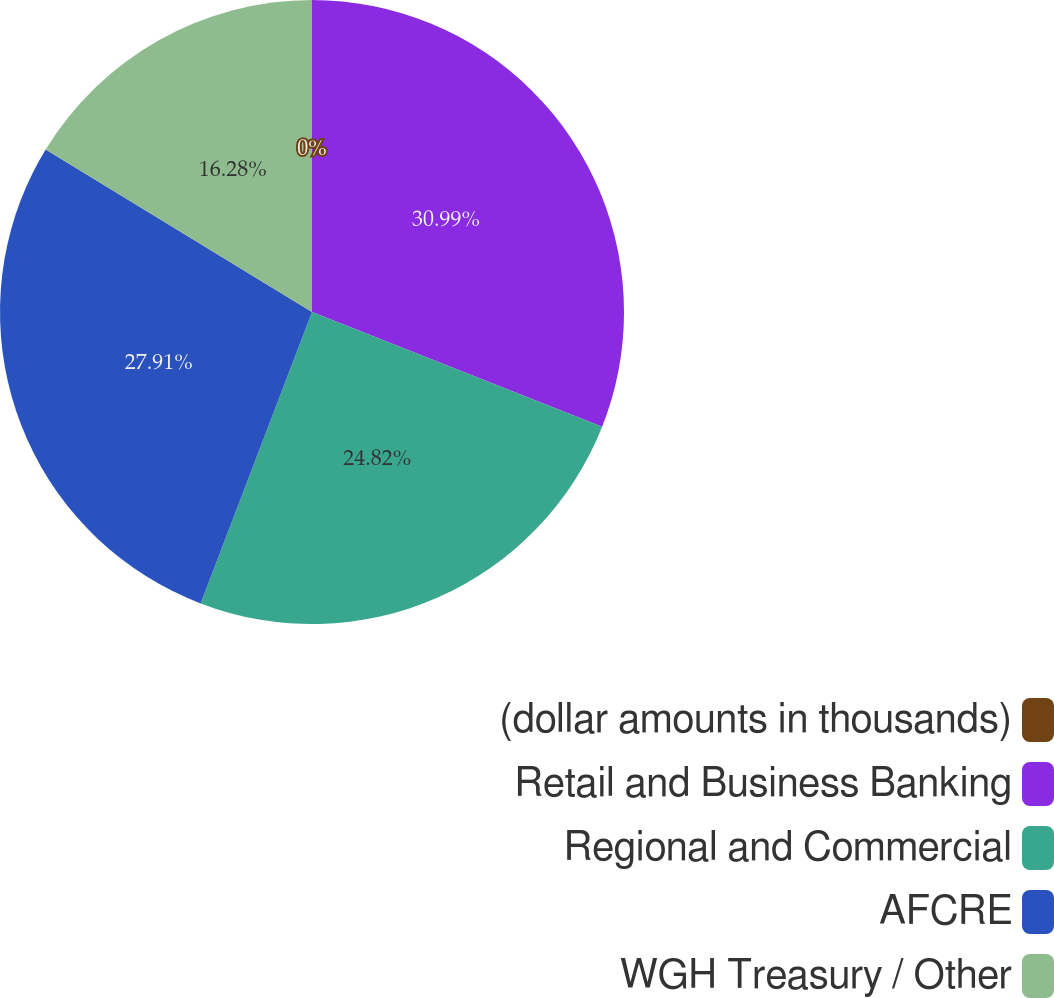<chart> <loc_0><loc_0><loc_500><loc_500><pie_chart><fcel>(dollar amounts in thousands)<fcel>Retail and Business Banking<fcel>Regional and Commercial<fcel>AFCRE<fcel>WGH Treasury / Other<nl><fcel>0.0%<fcel>30.99%<fcel>24.82%<fcel>27.91%<fcel>16.28%<nl></chart> 